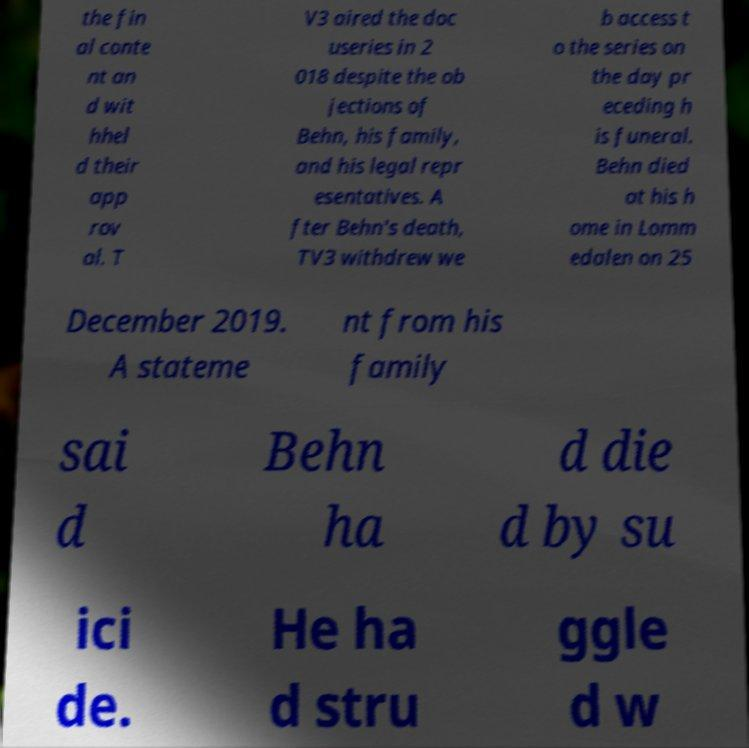Please read and relay the text visible in this image. What does it say? the fin al conte nt an d wit hhel d their app rov al. T V3 aired the doc useries in 2 018 despite the ob jections of Behn, his family, and his legal repr esentatives. A fter Behn's death, TV3 withdrew we b access t o the series on the day pr eceding h is funeral. Behn died at his h ome in Lomm edalen on 25 December 2019. A stateme nt from his family sai d Behn ha d die d by su ici de. He ha d stru ggle d w 